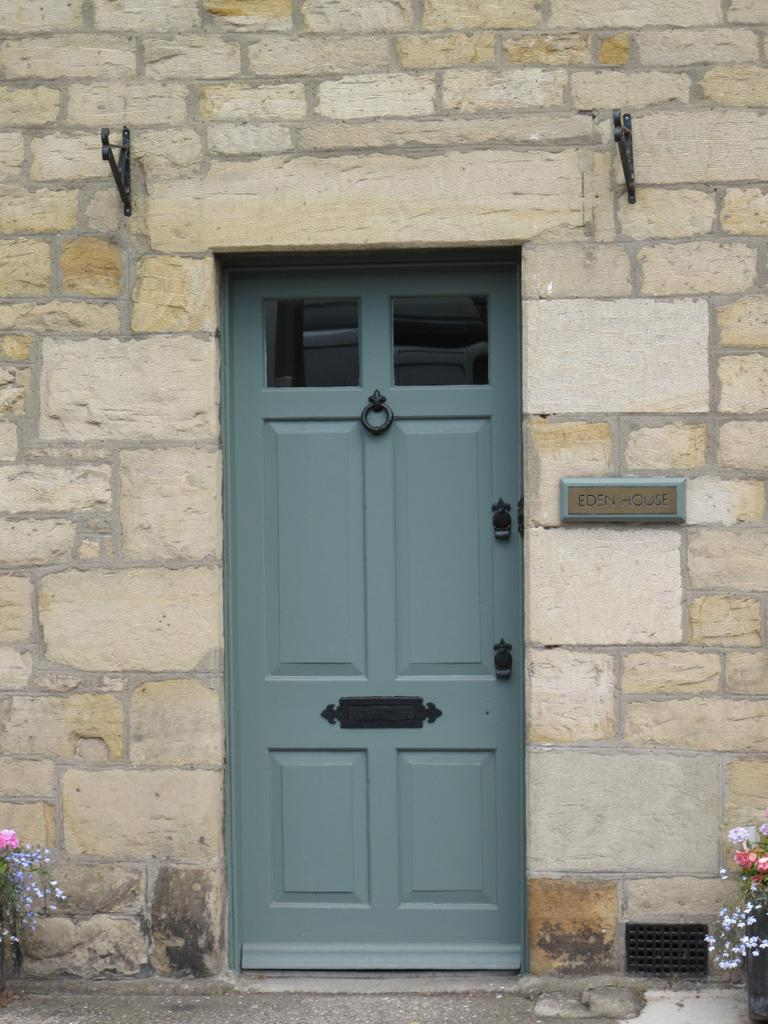What type of structure is visible in the image? There is a building in the image. What feature of the building is mentioned in the facts? The building has a door. Is there any additional information about the building provided? Yes, there is a nameplate on the wall of the building. What can be seen in the background of the image? There are two flower plants in the background of the image. What type of van is parked in front of the building in the image? There is no van present in the image; it only features a building, a door, a nameplate, and two flower plants in the background. 